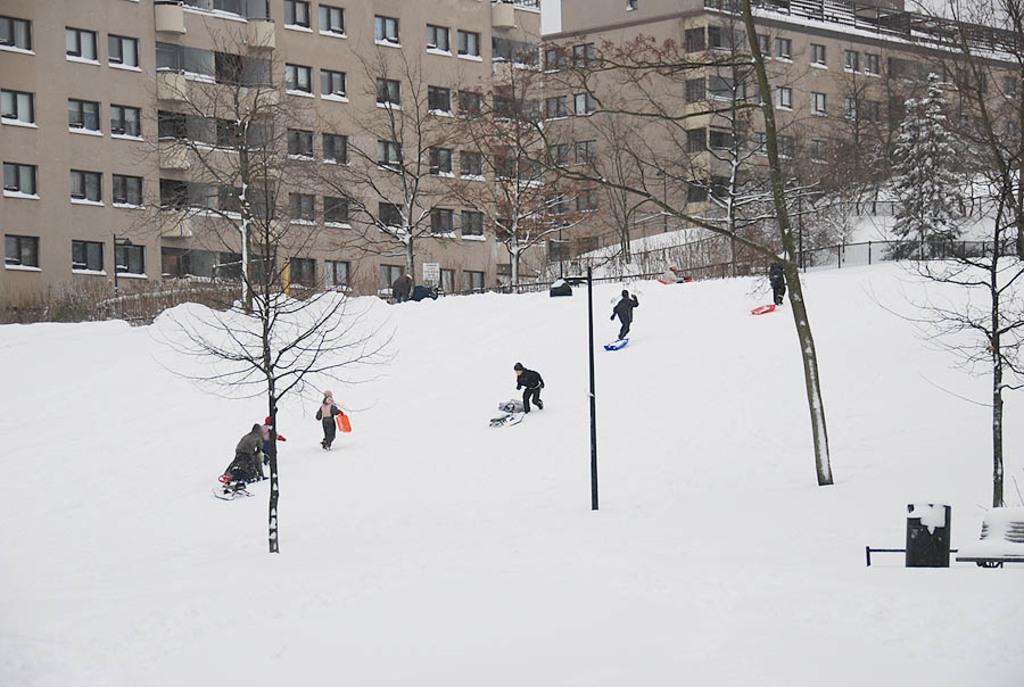In one or two sentences, can you explain what this image depicts? In this image we can see a group of people standing on the snow. One person is holding an object in his hand. In the center of the image we can some objects placed on the ground. In the background, we can see a trash bin placed on the ground, a group of trees, fence, buildings with windows, light poles and the sky. 